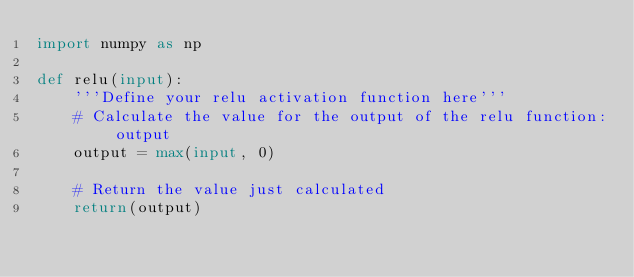Convert code to text. <code><loc_0><loc_0><loc_500><loc_500><_Python_>import numpy as np

def relu(input):
    '''Define your relu activation function here'''
    # Calculate the value for the output of the relu function: output
    output = max(input, 0)
    
    # Return the value just calculated
    return(output)
</code> 